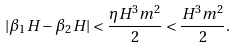<formula> <loc_0><loc_0><loc_500><loc_500>| \beta _ { 1 } H - \beta _ { 2 } H | < \frac { \eta H ^ { 3 } m ^ { 2 } } { 2 } < \frac { H ^ { 3 } m ^ { 2 } } { 2 } .</formula> 